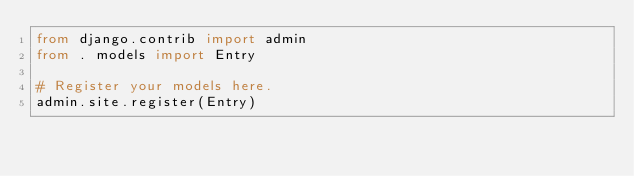<code> <loc_0><loc_0><loc_500><loc_500><_Python_>from django.contrib import admin
from . models import Entry

# Register your models here.
admin.site.register(Entry)</code> 